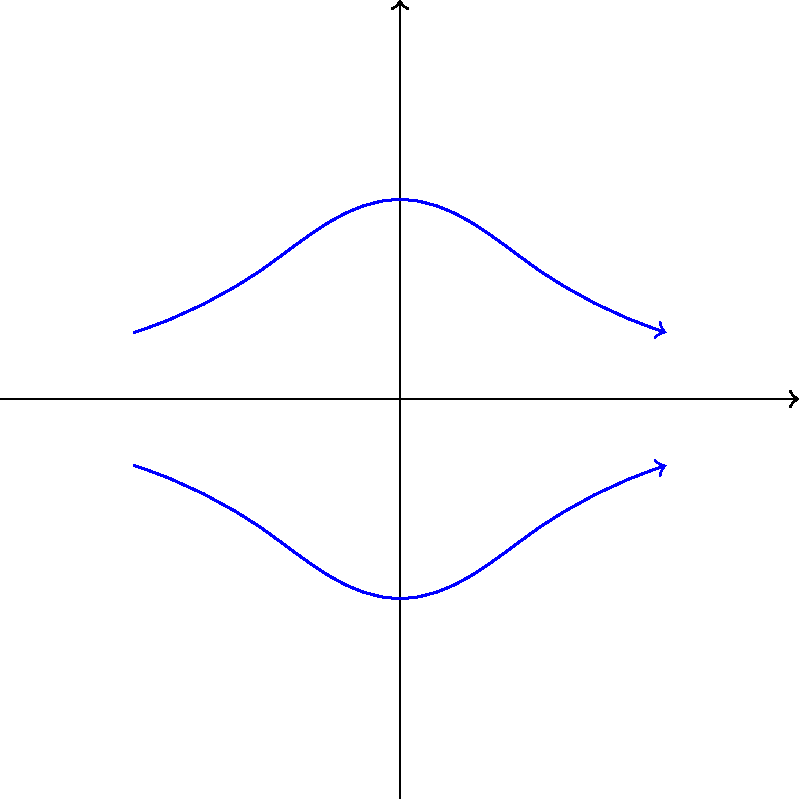As a software developer experienced in working with Oracle Endeca, you're tasked with visualizing electromagnetic field data for a new project. Given the diagram showing electric field lines (blue) and magnetic field lines (red) for a plane electromagnetic wave propagating in the positive x-direction, determine the direction of energy flow (Poynting vector) of this wave. To determine the direction of energy flow (Poynting vector) in an electromagnetic wave, we need to follow these steps:

1. Identify the directions of the electric field ($\mathbf{E}$) and magnetic field ($\mathbf{B}$):
   - The electric field ($\mathbf{E}$) is represented by blue lines, oscillating in the y-direction.
   - The magnetic field ($\mathbf{B}$) is represented by red dashed lines, oscillating in the z-direction (perpendicular to the page).

2. Recall the formula for the Poynting vector ($\mathbf{S}$):
   $$\mathbf{S} = \frac{1}{\mu_0} \mathbf{E} \times \mathbf{B}$$
   where $\mu_0$ is the permeability of free space.

3. Apply the right-hand rule for cross products:
   - Point your fingers in the direction of $\mathbf{E}$ (y-direction).
   - Curl them towards the direction of $\mathbf{B}$ (z-direction).
   - Your thumb will point in the direction of $\mathbf{E} \times \mathbf{B}$ (x-direction).

4. Conclude that the Poynting vector $\mathbf{S}$ points in the positive x-direction, which is the direction of wave propagation.

This result is consistent with the fact that electromagnetic waves are transverse waves, where energy propagates perpendicular to the oscillating electric and magnetic fields.
Answer: Positive x-direction 